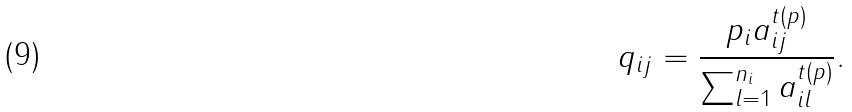Convert formula to latex. <formula><loc_0><loc_0><loc_500><loc_500>q _ { i j } = \frac { p _ { i } a _ { i j } ^ { t ( p ) } } { \sum _ { l = 1 } ^ { n _ { i } } a _ { i l } ^ { t ( p ) } } .</formula> 